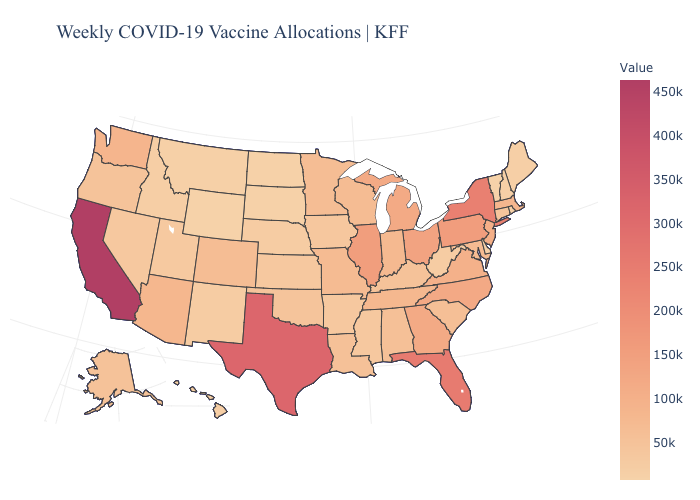Does Washington have a higher value than Pennsylvania?
Short answer required. No. Does California have the highest value in the USA?
Give a very brief answer. Yes. Which states hav the highest value in the West?
Write a very short answer. California. Among the states that border North Carolina , which have the highest value?
Quick response, please. Georgia. Among the states that border Arkansas , does Mississippi have the lowest value?
Write a very short answer. Yes. Which states hav the highest value in the MidWest?
Be succinct. Illinois. 